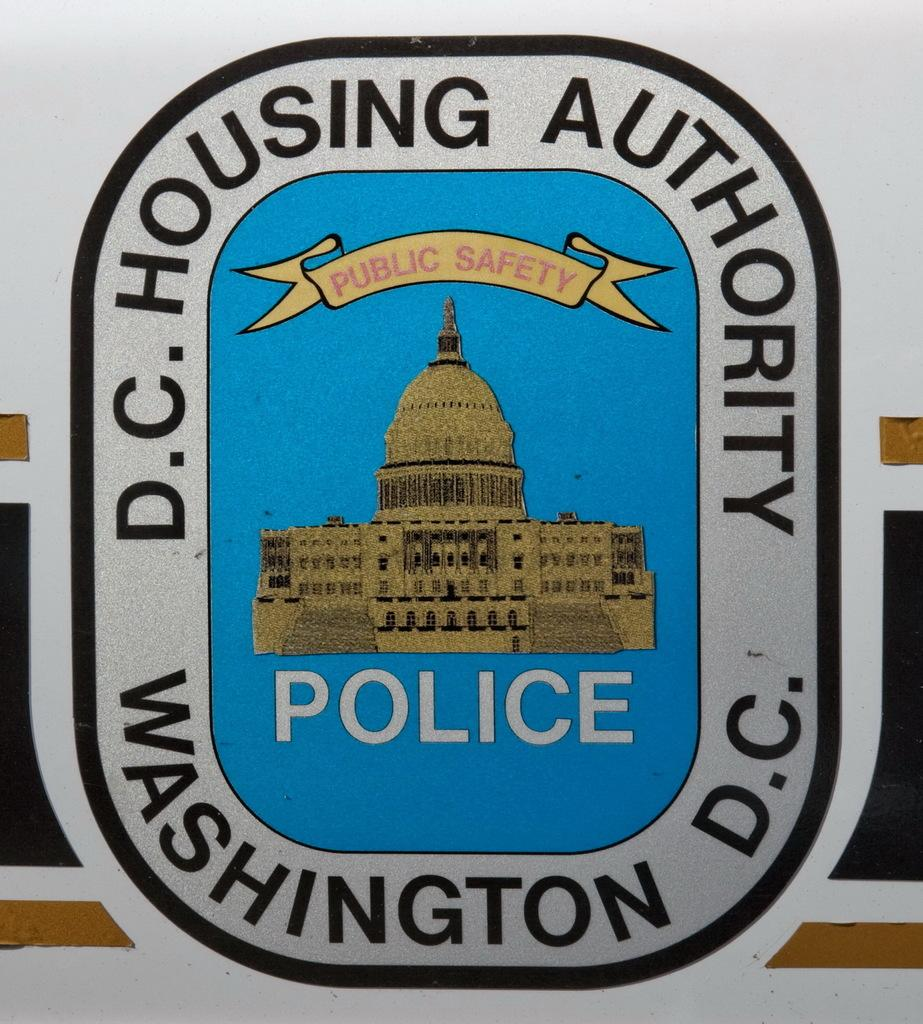Provide a one-sentence caption for the provided image. A sticker that is for the D.C. Housing Authority Police in Washington D.C. 